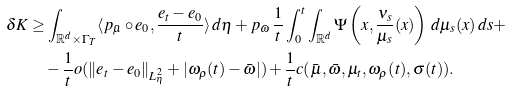Convert formula to latex. <formula><loc_0><loc_0><loc_500><loc_500>\delta K & \geq \int _ { \mathbb { R } ^ { d } \times \Gamma _ { T } } \langle p _ { \bar { \mu } } \circ e _ { 0 } , \frac { e _ { t } - e _ { 0 } } { t } \rangle \, d \boldsymbol \eta + p _ { \bar { \omega } } \, \frac { 1 } { t } \int _ { 0 } ^ { t } \int _ { \mathbb { R } ^ { d } } \Psi \left ( x , \frac { \nu _ { s } } { \mu _ { s } } ( x ) \right ) \, d \mu _ { s } ( x ) \, d s + \\ & \quad - \frac { 1 } { t } o ( \| e _ { t } - e _ { 0 } \| _ { L ^ { 2 } _ { \boldsymbol \eta } } + | \omega _ { \rho } ( t ) - \bar { \omega } | ) + \frac { 1 } { t } c ( \bar { \mu } , \bar { \omega } , \mu _ { t } , \omega _ { \rho } ( t ) , \sigma ( t ) ) .</formula> 